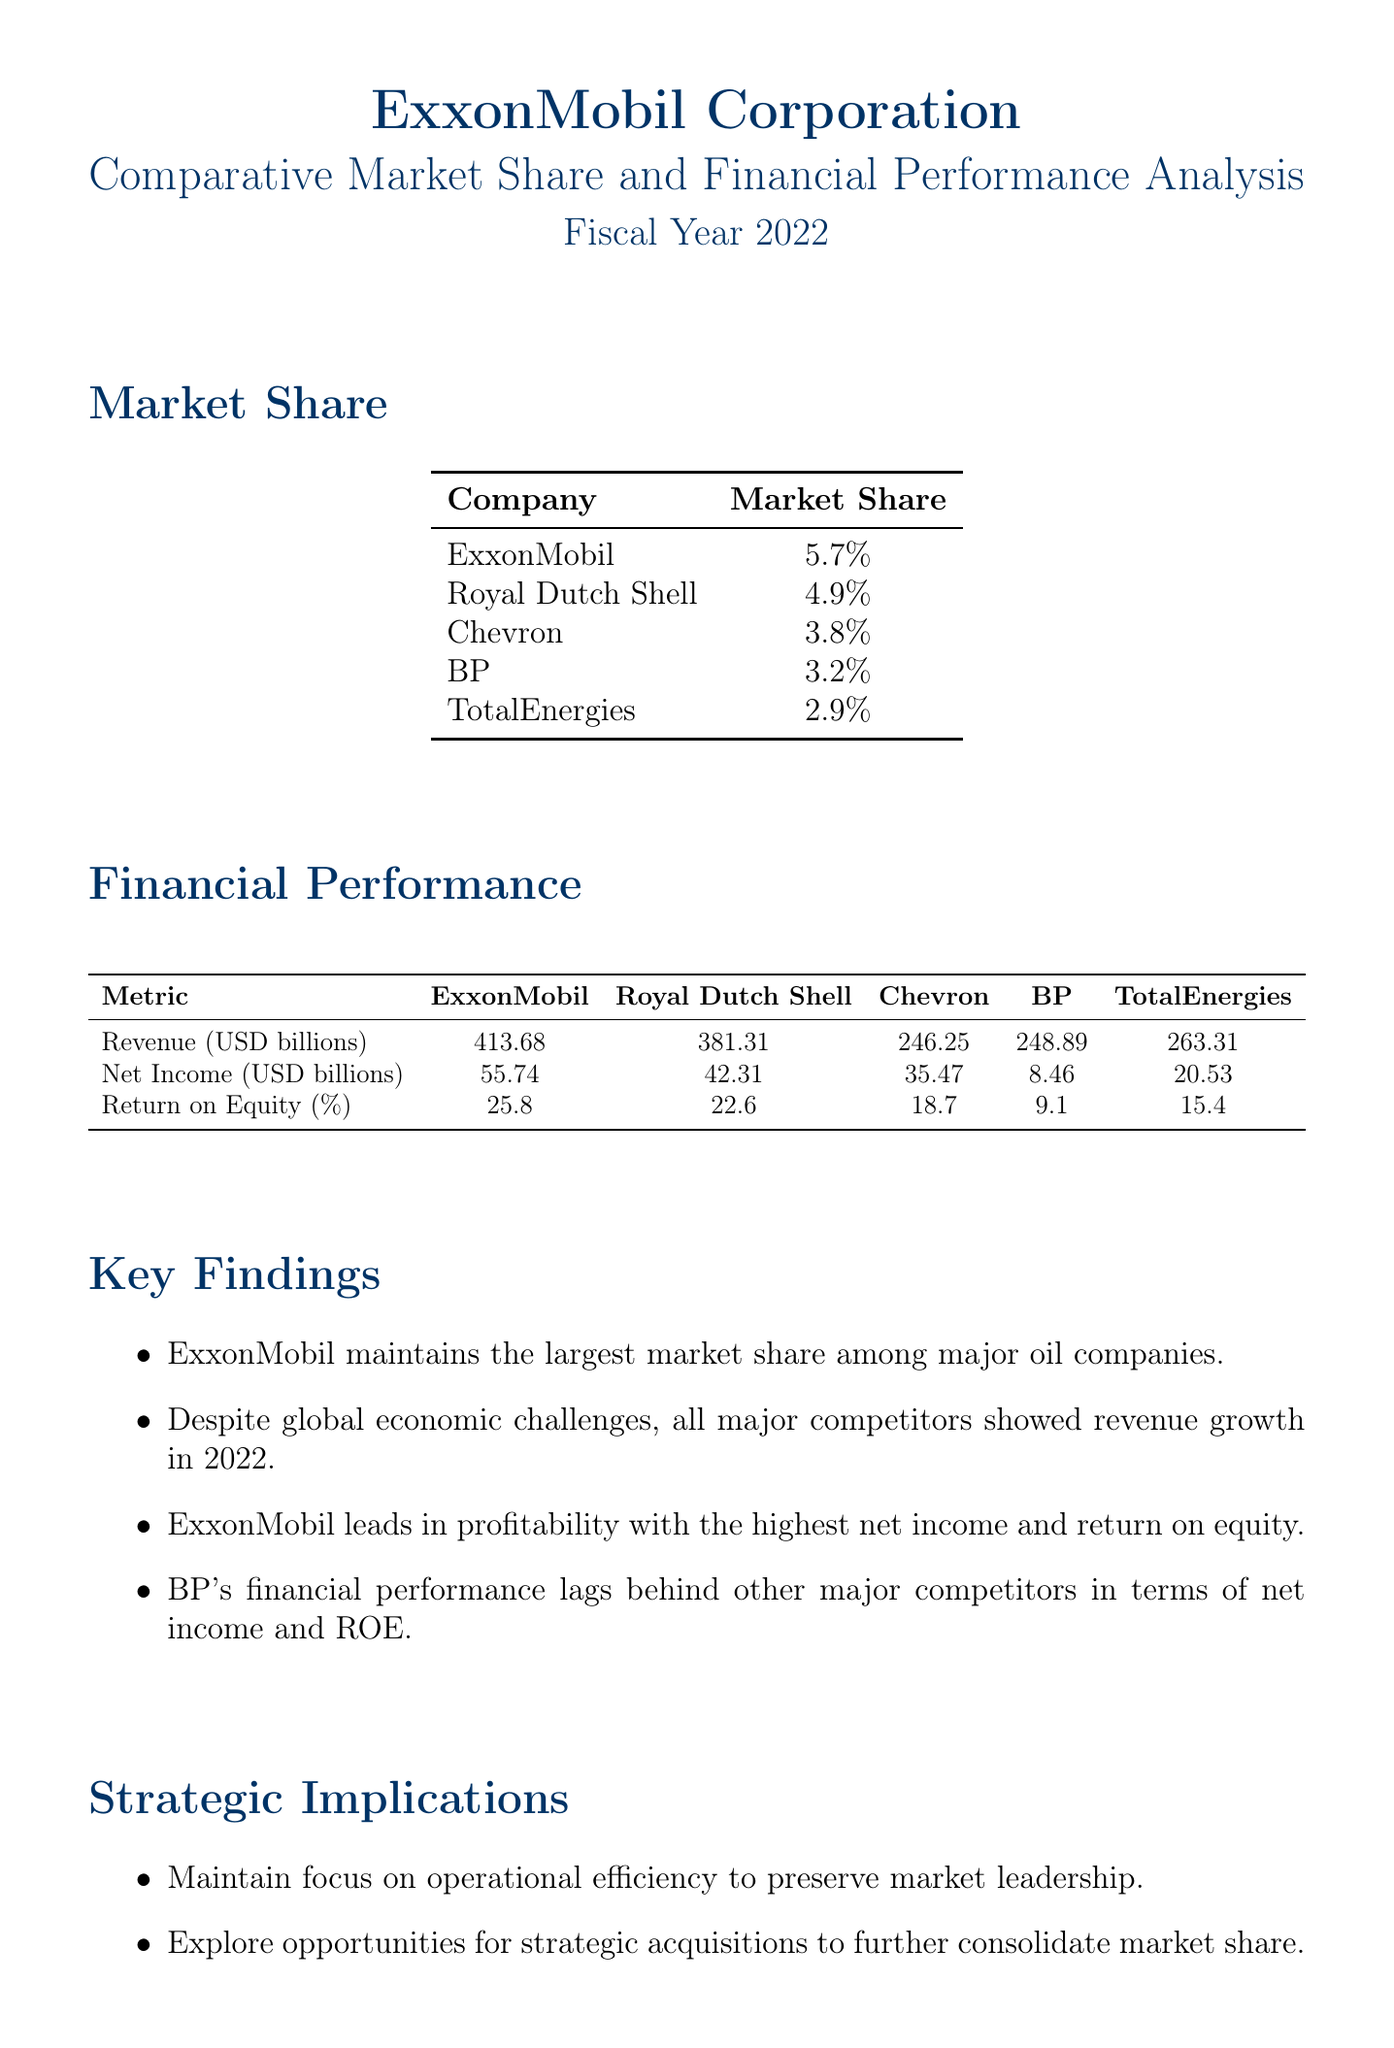what is ExxonMobil's market share? The document states that ExxonMobil's market share is 5.7%.
Answer: 5.7% how much was ExxonMobil's revenue in 2022? The document provides that ExxonMobil's revenue for the fiscal year 2022 was 413.68 billion USD.
Answer: 413.68 billion USD which company had the lowest net income? The analysis indicates that BP had the lowest net income among the competitors, recorded at 8.46 billion USD.
Answer: BP what is the return on equity for TotalEnergies? According to the financial metrics, TotalEnergies had a return on equity of 15.4%.
Answer: 15.4% what was the trend in revenue growth among competitors? The document notes that all major competitors showed revenue growth in 2022 despite global challenges.
Answer: Revenue growth which company has the highest return on equity? The document states that ExxonMobil leads with the highest return on equity at 25.8%.
Answer: ExxonMobil list one strategic implication mentioned in the report. The report includes several strategic implications; one example provided is to "explore opportunities for strategic acquisitions."
Answer: explore opportunities for strategic acquisitions how many key competitors are listed in the document? There are four key competitors mentioned in the market share data section of the document.
Answer: Four what is the total net income for Chevron? The net income for Chevron, as specified in the financial metrics section, was 35.47 billion USD.
Answer: 35.47 billion USD 